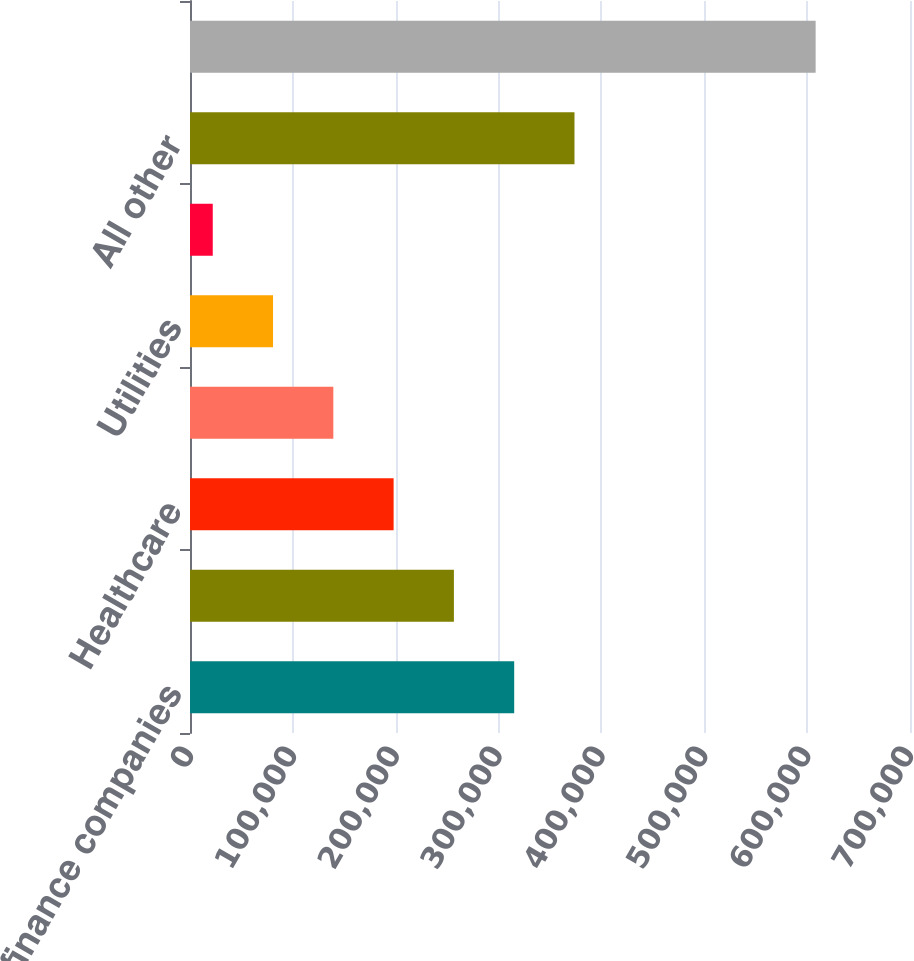Convert chart to OTSL. <chart><loc_0><loc_0><loc_500><loc_500><bar_chart><fcel>Banks and finance companies<fcel>Real estate<fcel>Healthcare<fcel>Consumer products<fcel>Utilities<fcel>Retail and consumer services<fcel>All other<fcel>Total excluding HFS<nl><fcel>315191<fcel>256577<fcel>197963<fcel>139350<fcel>80735.8<fcel>22122<fcel>373805<fcel>608260<nl></chart> 